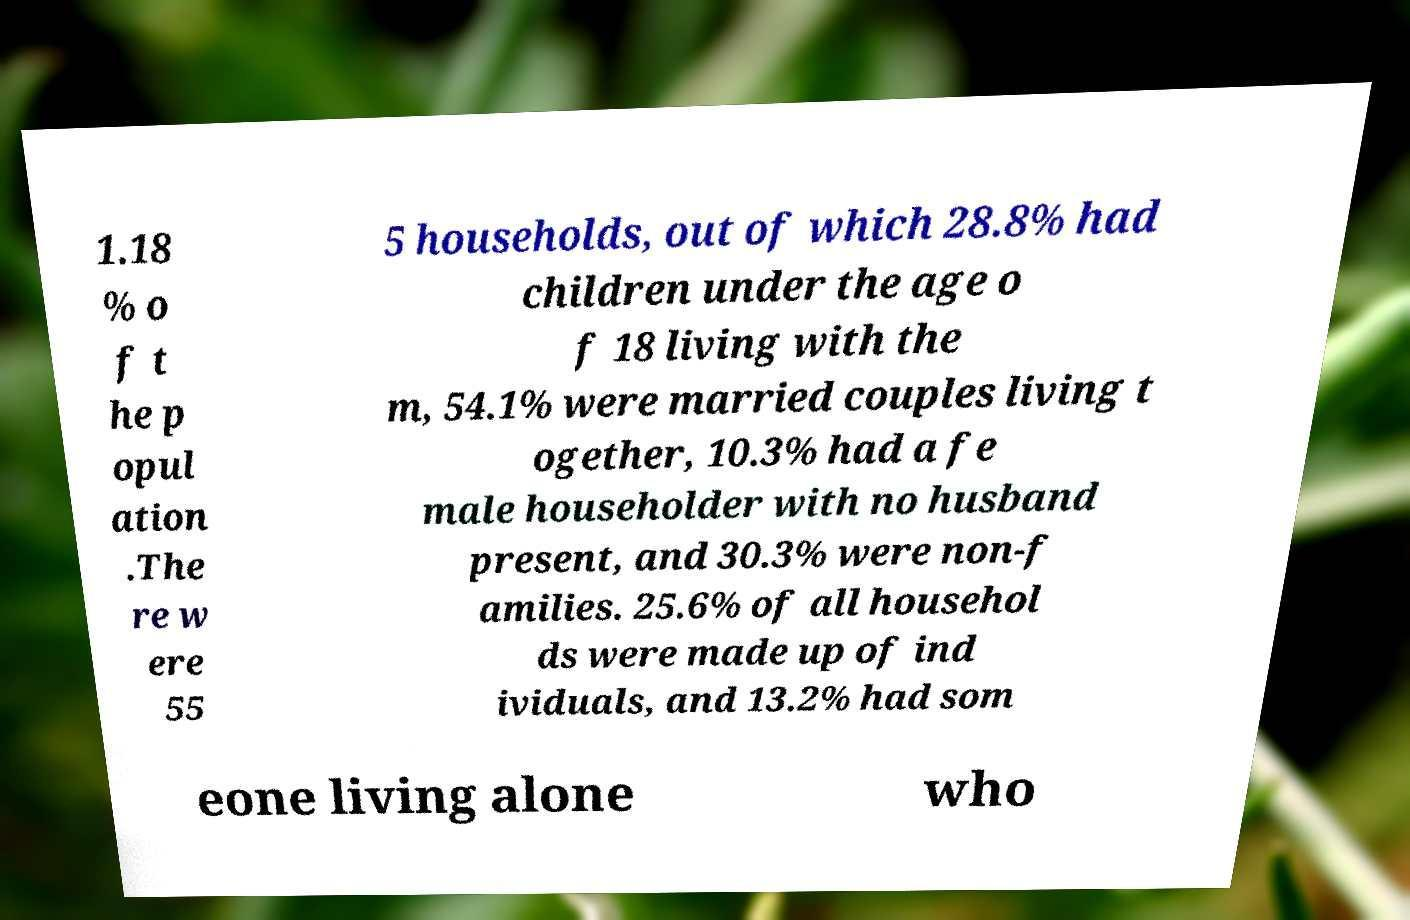Could you assist in decoding the text presented in this image and type it out clearly? 1.18 % o f t he p opul ation .The re w ere 55 5 households, out of which 28.8% had children under the age o f 18 living with the m, 54.1% were married couples living t ogether, 10.3% had a fe male householder with no husband present, and 30.3% were non-f amilies. 25.6% of all househol ds were made up of ind ividuals, and 13.2% had som eone living alone who 